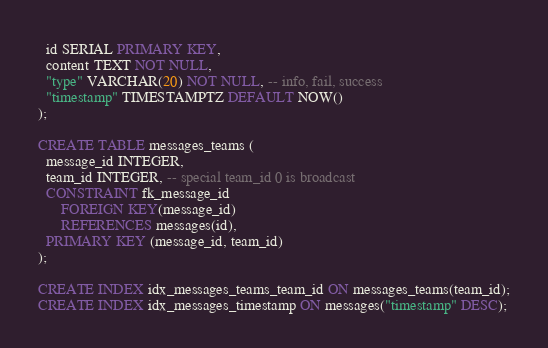Convert code to text. <code><loc_0><loc_0><loc_500><loc_500><_SQL_>  id SERIAL PRIMARY KEY,
  content TEXT NOT NULL,
  "type" VARCHAR(20) NOT NULL, -- info, fail, success
  "timestamp" TIMESTAMPTZ DEFAULT NOW()
);

CREATE TABLE messages_teams (
  message_id INTEGER,
  team_id INTEGER, -- special team_id 0 is broadcast
  CONSTRAINT fk_message_id
      FOREIGN KEY(message_id)
	  REFERENCES messages(id),
  PRIMARY KEY (message_id, team_id)
);

CREATE INDEX idx_messages_teams_team_id ON messages_teams(team_id);
CREATE INDEX idx_messages_timestamp ON messages("timestamp" DESC);
</code> 